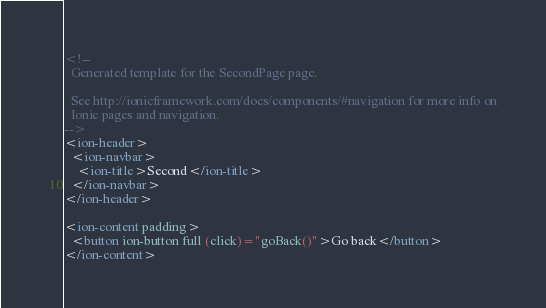<code> <loc_0><loc_0><loc_500><loc_500><_HTML_><!--
  Generated template for the SecondPage page.

  See http://ionicframework.com/docs/components/#navigation for more info on
  Ionic pages and navigation.
-->
<ion-header>
  <ion-navbar>
    <ion-title>Second</ion-title>
  </ion-navbar>
</ion-header>
 
<ion-content padding>
  <button ion-button full (click)="goBack()">Go back</button>
</ion-content>
</code> 